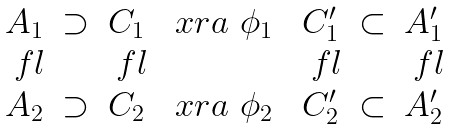Convert formula to latex. <formula><loc_0><loc_0><loc_500><loc_500>\begin{matrix} A _ { 1 } & \supset & C _ { 1 } & \ x r a { \ \phi _ { 1 } \ } & C ^ { \prime } _ { 1 } & \subset & A ^ { \prime } _ { 1 } \\ \ f l & & \ f l & & \ f l & & \ f l \\ A _ { 2 } & \supset & C _ { 2 } & \ x r a { \ \phi _ { 2 } \ } & C ^ { \prime } _ { 2 } & \subset & A ^ { \prime } _ { 2 } \end{matrix}</formula> 